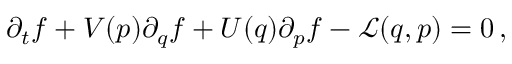<formula> <loc_0><loc_0><loc_500><loc_500>{ \partial _ { t } f } + V ( p ) { \partial _ { q } f } + U ( q ) { \partial _ { p } f } - \mathcal { L } ( q , p ) = 0 \, ,</formula> 